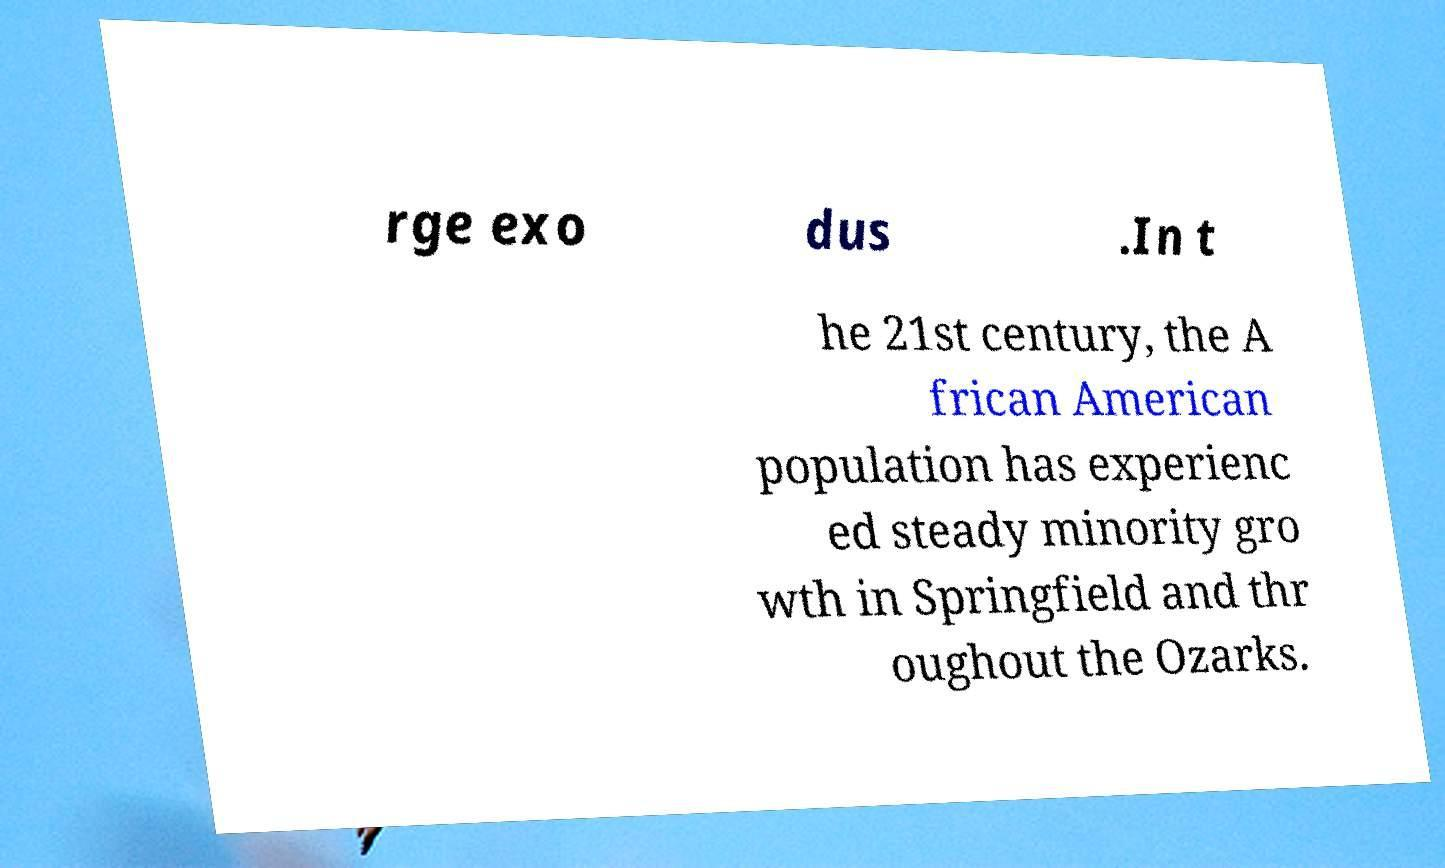Please read and relay the text visible in this image. What does it say? rge exo dus .In t he 21st century, the A frican American population has experienc ed steady minority gro wth in Springfield and thr oughout the Ozarks. 